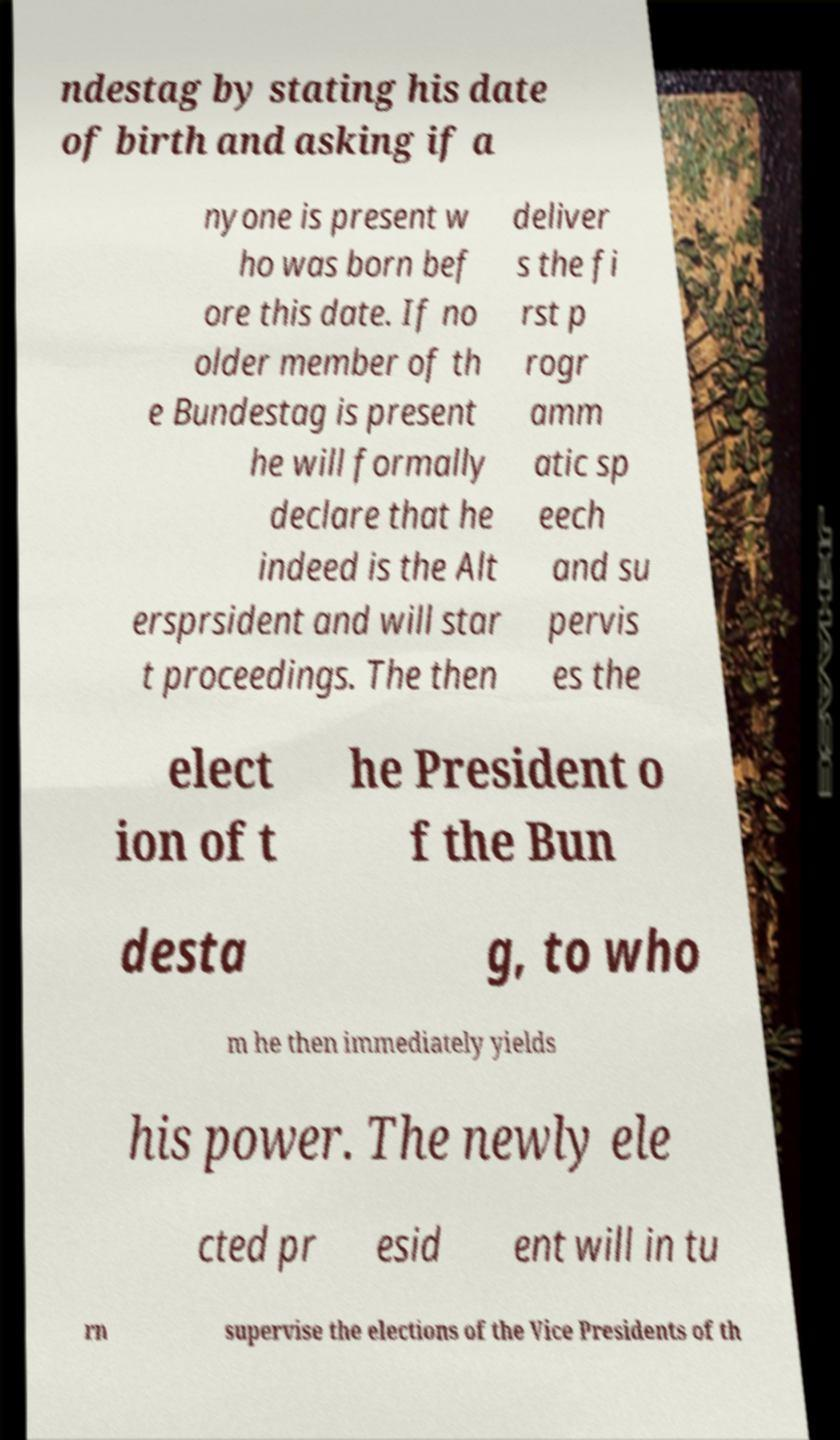Could you extract and type out the text from this image? ndestag by stating his date of birth and asking if a nyone is present w ho was born bef ore this date. If no older member of th e Bundestag is present he will formally declare that he indeed is the Alt ersprsident and will star t proceedings. The then deliver s the fi rst p rogr amm atic sp eech and su pervis es the elect ion of t he President o f the Bun desta g, to who m he then immediately yields his power. The newly ele cted pr esid ent will in tu rn supervise the elections of the Vice Presidents of th 